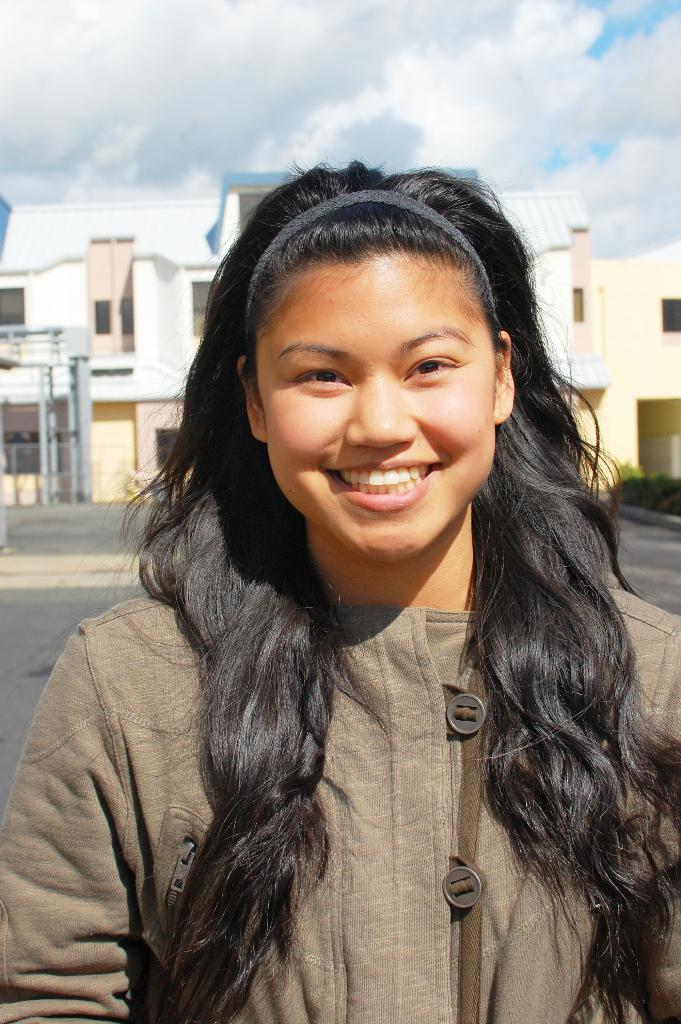What is the main subject of the image? There is a person standing in the image. What can be seen in the background of the image? There are buildings, plants, a fence, iron rods, and a cloudy sky visible in the background of the image. What color is the ink used by the person in the image? There is no ink present in the image, as it features a person standing with various elements in the background. 